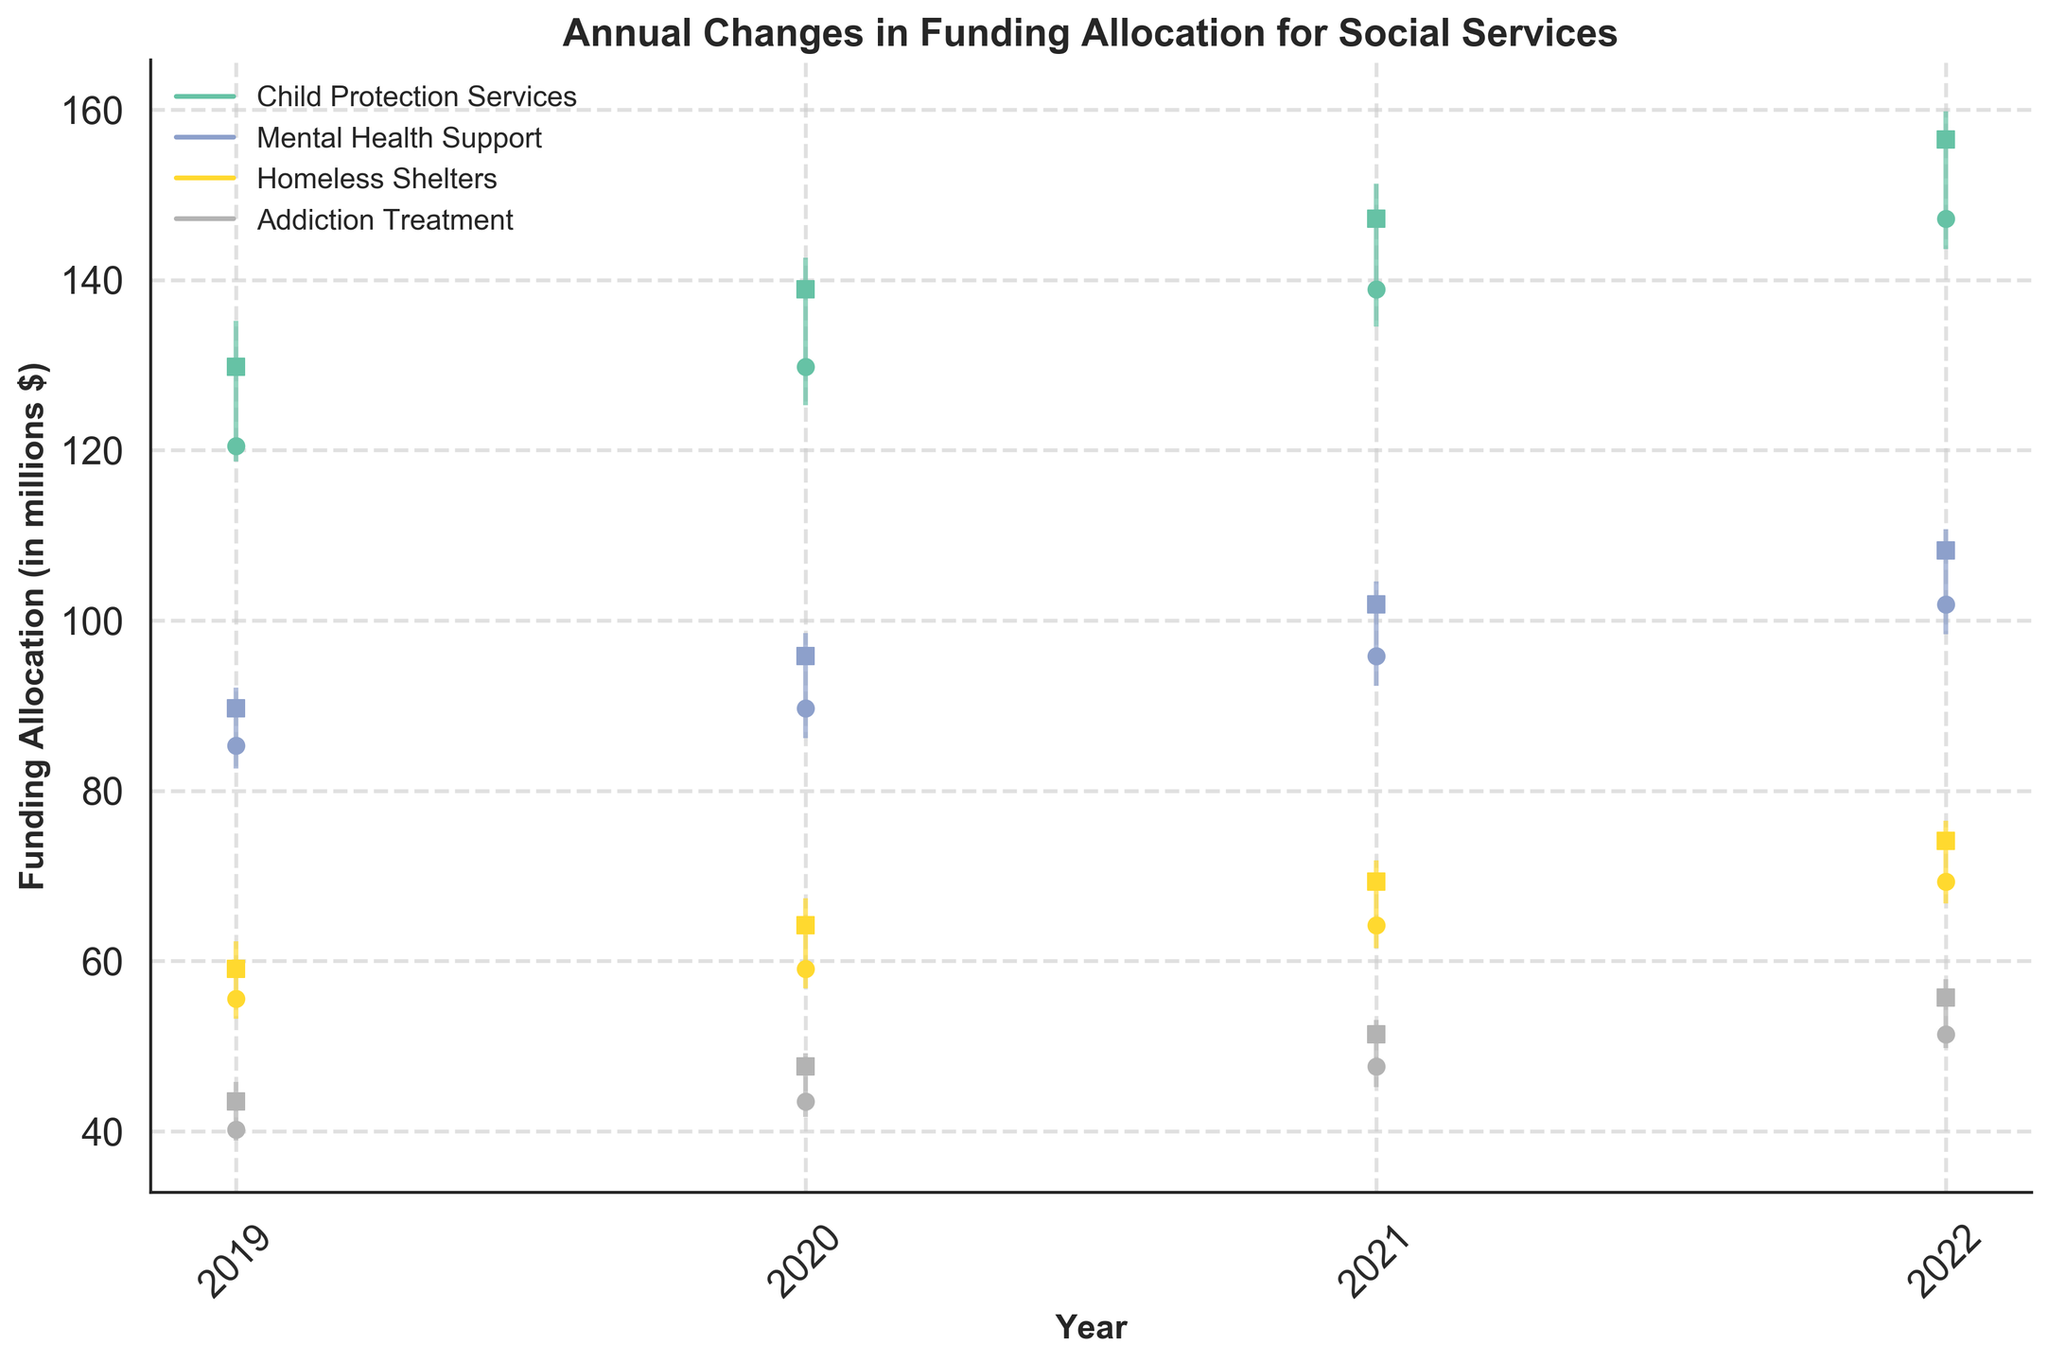What is the title of the figure? The title is usually at the top of the figure, and it directly states the main subject of the visualization.
Answer: Annual Changes in Funding Allocation for Social Services What is the range of funding allocation for Homeless Shelters in 2021? To determine the range, subtract the lowest value (Low) from the highest value (High) for Homeless Shelters in 2021. According to the data, the range is 71.8 - 61.5.
Answer: 10.3 Which social service had the highest closing funding allocation in 2022? Compare the 'Close' values for all social services in 2022. The highest value corresponds to Child Protection Services with a close of 156.5.
Answer: Child Protection Services How did the funding allocation for Addiction Treatment change from 2019 to 2022? Look at the 'Close' values for Addiction Treatment from 2019 (43.5) to 2022 (55.7) and calculate the difference. This shows an increase in funding.
Answer: Increased by 12.2 What's the average opening funding allocation for Child Protection Services from 2019 to 2022? Add the 'Open' values for Child Protection Services from 2019 (120.5), 2020 (129.8), 2021 (138.9), and 2022 (147.2) and then divide by 4. (120.5 + 129.8 + 138.9 + 147.2) / 4.
Answer: 134.1 Which year had the smallest range for Mental Health Support funding allocation? Calculate the range (High - Low) for each year for Mental Health Support and compare them. The smallest range is in 2022: 110.7 - 98.4 = 12.3.
Answer: 2022 Did the funding allocation for Homeless Shelters consistently increase from 2019 to 2022? Check the 'Close' values for each year from 2019 to 2022 (59.1, 64.2, 69.3, 74.1). Each subsequent year has a higher value, indicating consistent increase.
Answer: Yes Which social service saw the most significant percentage increase in funding allocation from 2019 to 2022? Calculate the percentage increase for each service ('Close' in 2022 - 'Close' in 2019) / 'Close' in 2019 * 100, and compare. Mental Health Support: ((108.2-89.7)/89.7)*100 = 20.7%, Child Protection Services: ((156.5-129.8)/129.8)*100 = 20.5%, etc.
Answer: Mental Health Support What was the low funding allocation for Mental Health Support in 2020? Refer to the 'Low' value for Mental Health Support in the year 2020. The data indicates it is 86.2 million dollars.
Answer: 86.2 